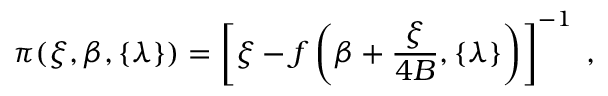Convert formula to latex. <formula><loc_0><loc_0><loc_500><loc_500>\pi ( \xi , \beta , \{ \lambda \} ) = \left [ \xi - f \left ( \beta + \frac { \xi } { 4 B } , \{ \lambda \} \right ) \right ] ^ { - 1 } \, ,</formula> 